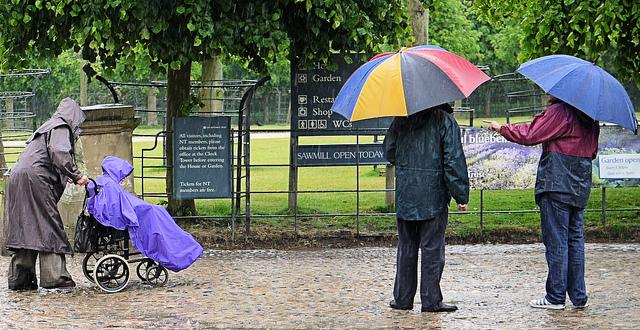What is the purple outfit the woman is wearing called? Please explain your reasoning. poncho. The woman in the wheelchair is wearing a purple poncho which keeps her dry in the rain. 